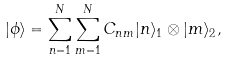Convert formula to latex. <formula><loc_0><loc_0><loc_500><loc_500>| \phi \rangle = \sum _ { n = 1 } ^ { N } \sum _ { m = 1 } ^ { N } C _ { n m } | n \rangle _ { 1 } \otimes | m \rangle _ { 2 } ,</formula> 